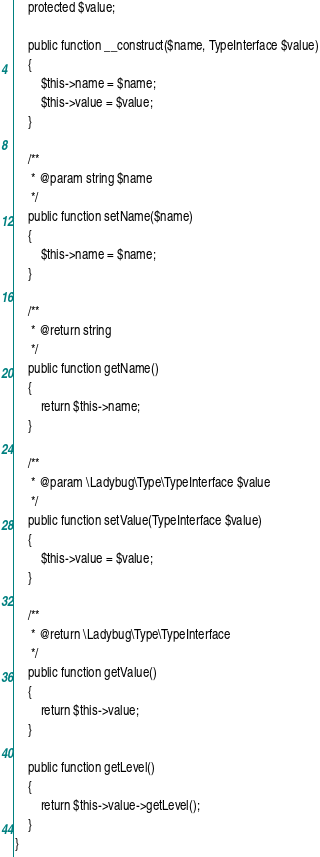Convert code to text. <code><loc_0><loc_0><loc_500><loc_500><_PHP_>    protected $value;

    public function __construct($name, TypeInterface $value)
    {
        $this->name = $name;
        $this->value = $value;
    }

    /**
     * @param string $name
     */
    public function setName($name)
    {
        $this->name = $name;
    }

    /**
     * @return string
     */
    public function getName()
    {
        return $this->name;
    }

    /**
     * @param \Ladybug\Type\TypeInterface $value
     */
    public function setValue(TypeInterface $value)
    {
        $this->value = $value;
    }

    /**
     * @return \Ladybug\Type\TypeInterface
     */
    public function getValue()
    {
        return $this->value;
    }

    public function getLevel()
    {
        return $this->value->getLevel();
    }
}
</code> 